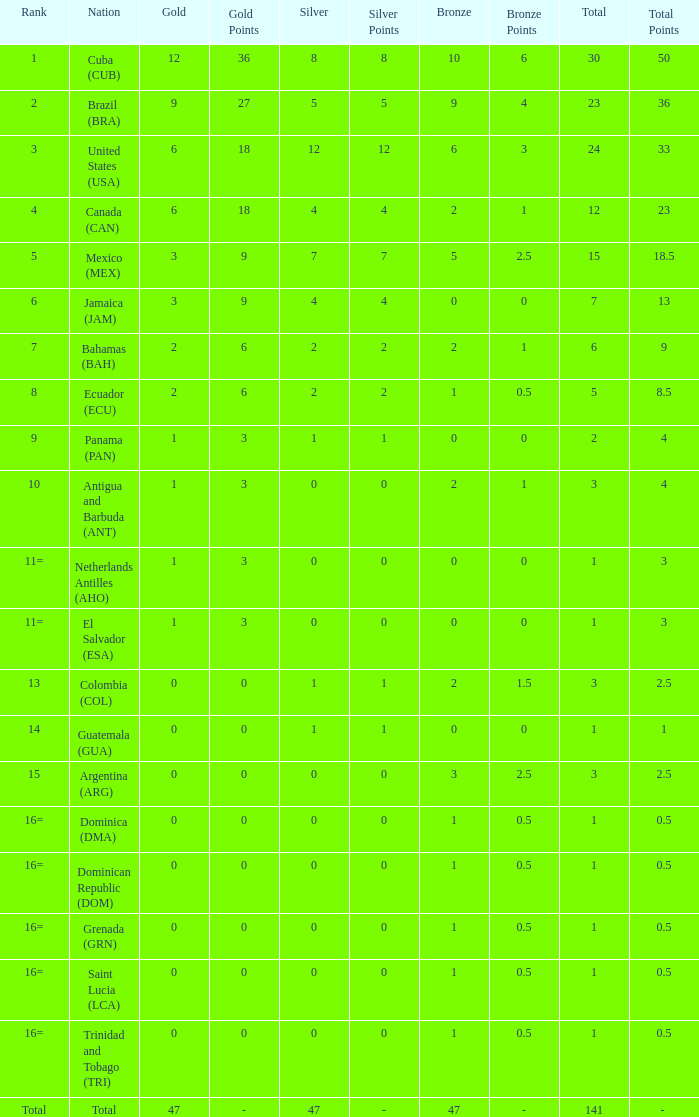What is the average silver with more than 0 gold, a Rank of 1, and a Total smaller than 30? None. 